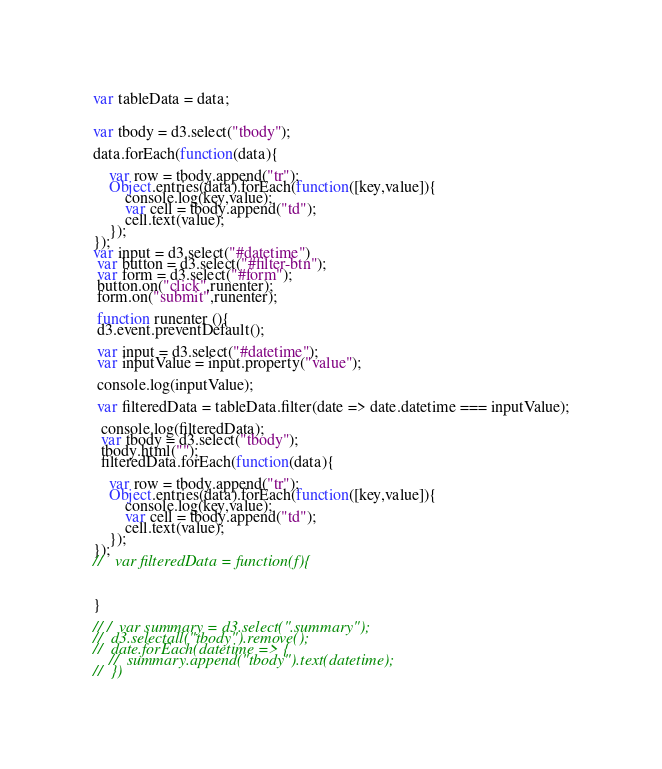Convert code to text. <code><loc_0><loc_0><loc_500><loc_500><_JavaScript_>var tableData = data;


var tbody = d3.select("tbody");

data.forEach(function(data){

    var row = tbody.append("tr");
    Object.entries(data).forEach(function([key,value]){
        console.log(key,value);
        var cell = tbody.append("td");
        cell.text(value);
    });
});
var input = d3.select("#datetime")
 var button = d3.select("#filter-btn");
 var form = d3.select("#form");
 button.on("click",runenter); 
 form.on("submit",runenter);

 function runenter (){ 
 d3.event.preventDefault();
 
 var input = d3.select("#datetime");
 var inputValue = input.property("value");

 console.log(inputValue);
 
 var filteredData = tableData.filter(date => date.datetime === inputValue);

  console.log(filteredData);
  var tbody = d3.select("tbody");
  tbody.html("");
  filteredData.forEach(function(data){

    var row = tbody.append("tr");
    Object.entries(data).forEach(function([key,value]){
        console.log(key,value);
        var cell = tbody.append("td");
        cell.text(value);
    });
});
//   var filteredData = function(f){

 
 
}
 
// /  var summary = d3.select(".summary");
//  d3.selectall("tbody").remove();
//  date.forEach(datetime => {
    //  summary.append("tbody").text(datetime);
//  })

</code> 